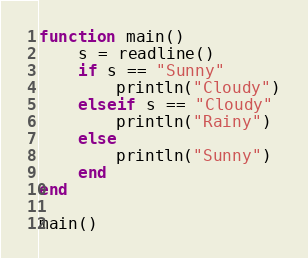<code> <loc_0><loc_0><loc_500><loc_500><_Julia_>function main()
    s = readline()
    if s == "Sunny"
        println("Cloudy")
    elseif s == "Cloudy"
        println("Rainy")
    else
        println("Sunny")
    end
end

main()</code> 